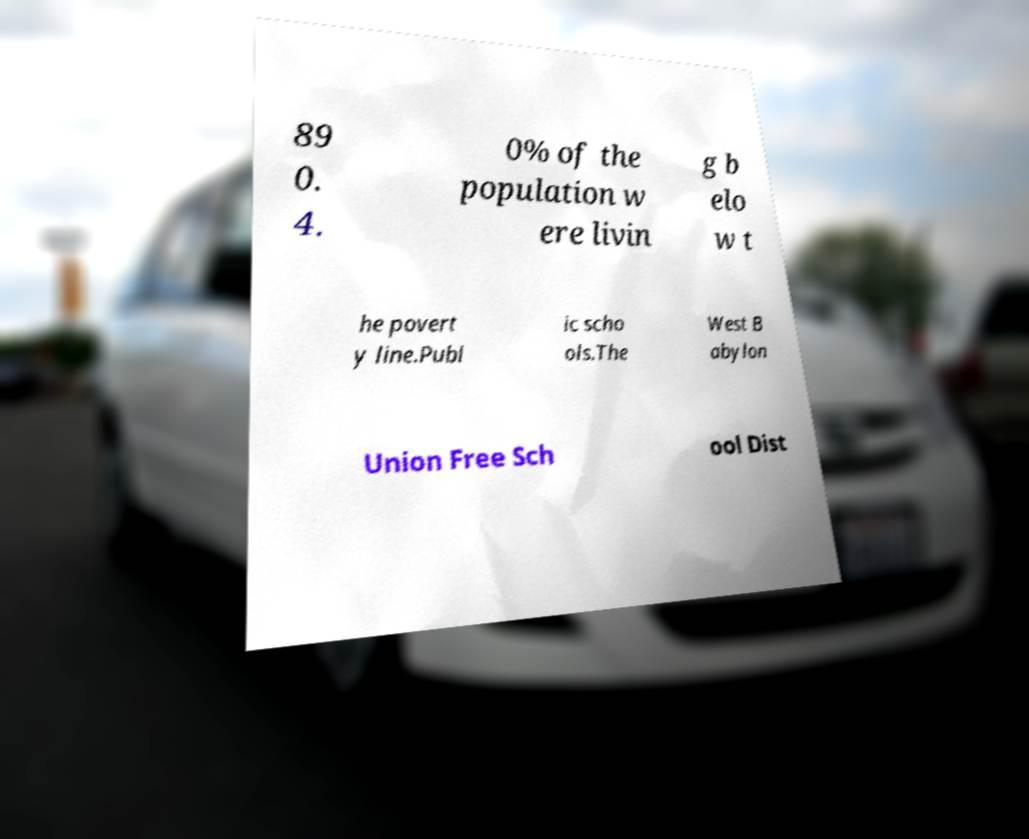There's text embedded in this image that I need extracted. Can you transcribe it verbatim? 89 0. 4. 0% of the population w ere livin g b elo w t he povert y line.Publ ic scho ols.The West B abylon Union Free Sch ool Dist 